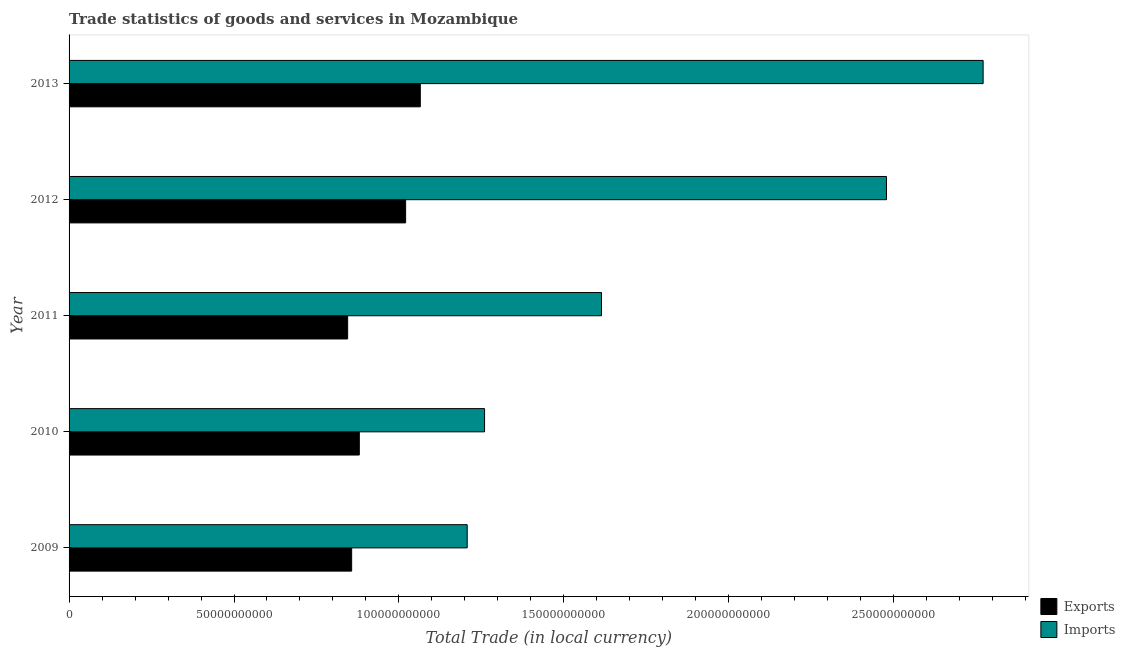How many different coloured bars are there?
Your answer should be compact. 2. How many bars are there on the 4th tick from the top?
Offer a terse response. 2. How many bars are there on the 5th tick from the bottom?
Give a very brief answer. 2. In how many cases, is the number of bars for a given year not equal to the number of legend labels?
Ensure brevity in your answer.  0. What is the export of goods and services in 2011?
Your answer should be very brief. 8.45e+1. Across all years, what is the maximum export of goods and services?
Give a very brief answer. 1.06e+11. Across all years, what is the minimum imports of goods and services?
Your answer should be compact. 1.21e+11. What is the total imports of goods and services in the graph?
Offer a terse response. 9.33e+11. What is the difference between the imports of goods and services in 2009 and that in 2011?
Give a very brief answer. -4.07e+1. What is the difference between the imports of goods and services in 2013 and the export of goods and services in 2012?
Provide a succinct answer. 1.75e+11. What is the average imports of goods and services per year?
Provide a succinct answer. 1.87e+11. In the year 2011, what is the difference between the export of goods and services and imports of goods and services?
Your answer should be compact. -7.70e+1. In how many years, is the imports of goods and services greater than 190000000000 LCU?
Your response must be concise. 2. What is the ratio of the export of goods and services in 2010 to that in 2012?
Your response must be concise. 0.86. Is the export of goods and services in 2009 less than that in 2013?
Offer a terse response. Yes. What is the difference between the highest and the second highest imports of goods and services?
Give a very brief answer. 2.93e+1. What is the difference between the highest and the lowest imports of goods and services?
Your answer should be compact. 1.56e+11. What does the 1st bar from the top in 2010 represents?
Provide a succinct answer. Imports. What does the 1st bar from the bottom in 2009 represents?
Provide a succinct answer. Exports. How many bars are there?
Your response must be concise. 10. Are all the bars in the graph horizontal?
Ensure brevity in your answer.  Yes. How many years are there in the graph?
Ensure brevity in your answer.  5. Are the values on the major ticks of X-axis written in scientific E-notation?
Your answer should be very brief. No. Does the graph contain any zero values?
Provide a succinct answer. No. Does the graph contain grids?
Ensure brevity in your answer.  No. Where does the legend appear in the graph?
Your response must be concise. Bottom right. What is the title of the graph?
Offer a very short reply. Trade statistics of goods and services in Mozambique. What is the label or title of the X-axis?
Your answer should be compact. Total Trade (in local currency). What is the Total Trade (in local currency) of Exports in 2009?
Your answer should be very brief. 8.57e+1. What is the Total Trade (in local currency) in Imports in 2009?
Offer a terse response. 1.21e+11. What is the Total Trade (in local currency) in Exports in 2010?
Your answer should be very brief. 8.80e+1. What is the Total Trade (in local currency) in Imports in 2010?
Your answer should be compact. 1.26e+11. What is the Total Trade (in local currency) in Exports in 2011?
Offer a terse response. 8.45e+1. What is the Total Trade (in local currency) in Imports in 2011?
Offer a terse response. 1.61e+11. What is the Total Trade (in local currency) of Exports in 2012?
Give a very brief answer. 1.02e+11. What is the Total Trade (in local currency) of Imports in 2012?
Your answer should be very brief. 2.48e+11. What is the Total Trade (in local currency) in Exports in 2013?
Offer a very short reply. 1.06e+11. What is the Total Trade (in local currency) of Imports in 2013?
Your answer should be compact. 2.77e+11. Across all years, what is the maximum Total Trade (in local currency) in Exports?
Your answer should be very brief. 1.06e+11. Across all years, what is the maximum Total Trade (in local currency) in Imports?
Your response must be concise. 2.77e+11. Across all years, what is the minimum Total Trade (in local currency) in Exports?
Your answer should be very brief. 8.45e+1. Across all years, what is the minimum Total Trade (in local currency) of Imports?
Your response must be concise. 1.21e+11. What is the total Total Trade (in local currency) in Exports in the graph?
Your answer should be very brief. 4.67e+11. What is the total Total Trade (in local currency) of Imports in the graph?
Give a very brief answer. 9.33e+11. What is the difference between the Total Trade (in local currency) in Exports in 2009 and that in 2010?
Keep it short and to the point. -2.32e+09. What is the difference between the Total Trade (in local currency) of Imports in 2009 and that in 2010?
Your response must be concise. -5.26e+09. What is the difference between the Total Trade (in local currency) in Exports in 2009 and that in 2011?
Provide a short and direct response. 1.22e+09. What is the difference between the Total Trade (in local currency) of Imports in 2009 and that in 2011?
Your answer should be compact. -4.07e+1. What is the difference between the Total Trade (in local currency) in Exports in 2009 and that in 2012?
Offer a very short reply. -1.64e+1. What is the difference between the Total Trade (in local currency) of Imports in 2009 and that in 2012?
Provide a succinct answer. -1.27e+11. What is the difference between the Total Trade (in local currency) of Exports in 2009 and that in 2013?
Provide a short and direct response. -2.08e+1. What is the difference between the Total Trade (in local currency) of Imports in 2009 and that in 2013?
Your answer should be compact. -1.56e+11. What is the difference between the Total Trade (in local currency) of Exports in 2010 and that in 2011?
Keep it short and to the point. 3.54e+09. What is the difference between the Total Trade (in local currency) in Imports in 2010 and that in 2011?
Your response must be concise. -3.55e+1. What is the difference between the Total Trade (in local currency) of Exports in 2010 and that in 2012?
Your answer should be compact. -1.40e+1. What is the difference between the Total Trade (in local currency) of Imports in 2010 and that in 2012?
Offer a terse response. -1.22e+11. What is the difference between the Total Trade (in local currency) in Exports in 2010 and that in 2013?
Offer a very short reply. -1.85e+1. What is the difference between the Total Trade (in local currency) in Imports in 2010 and that in 2013?
Offer a very short reply. -1.51e+11. What is the difference between the Total Trade (in local currency) of Exports in 2011 and that in 2012?
Offer a terse response. -1.76e+1. What is the difference between the Total Trade (in local currency) of Imports in 2011 and that in 2012?
Make the answer very short. -8.64e+1. What is the difference between the Total Trade (in local currency) in Exports in 2011 and that in 2013?
Provide a short and direct response. -2.20e+1. What is the difference between the Total Trade (in local currency) in Imports in 2011 and that in 2013?
Your answer should be compact. -1.16e+11. What is the difference between the Total Trade (in local currency) in Exports in 2012 and that in 2013?
Keep it short and to the point. -4.45e+09. What is the difference between the Total Trade (in local currency) in Imports in 2012 and that in 2013?
Your answer should be very brief. -2.93e+1. What is the difference between the Total Trade (in local currency) in Exports in 2009 and the Total Trade (in local currency) in Imports in 2010?
Your answer should be compact. -4.03e+1. What is the difference between the Total Trade (in local currency) in Exports in 2009 and the Total Trade (in local currency) in Imports in 2011?
Your response must be concise. -7.57e+1. What is the difference between the Total Trade (in local currency) of Exports in 2009 and the Total Trade (in local currency) of Imports in 2012?
Provide a short and direct response. -1.62e+11. What is the difference between the Total Trade (in local currency) of Exports in 2009 and the Total Trade (in local currency) of Imports in 2013?
Offer a very short reply. -1.91e+11. What is the difference between the Total Trade (in local currency) of Exports in 2010 and the Total Trade (in local currency) of Imports in 2011?
Your answer should be very brief. -7.34e+1. What is the difference between the Total Trade (in local currency) of Exports in 2010 and the Total Trade (in local currency) of Imports in 2012?
Your answer should be compact. -1.60e+11. What is the difference between the Total Trade (in local currency) of Exports in 2010 and the Total Trade (in local currency) of Imports in 2013?
Provide a succinct answer. -1.89e+11. What is the difference between the Total Trade (in local currency) in Exports in 2011 and the Total Trade (in local currency) in Imports in 2012?
Your response must be concise. -1.63e+11. What is the difference between the Total Trade (in local currency) of Exports in 2011 and the Total Trade (in local currency) of Imports in 2013?
Your answer should be compact. -1.93e+11. What is the difference between the Total Trade (in local currency) in Exports in 2012 and the Total Trade (in local currency) in Imports in 2013?
Your answer should be very brief. -1.75e+11. What is the average Total Trade (in local currency) in Exports per year?
Your response must be concise. 9.33e+1. What is the average Total Trade (in local currency) of Imports per year?
Offer a terse response. 1.87e+11. In the year 2009, what is the difference between the Total Trade (in local currency) in Exports and Total Trade (in local currency) in Imports?
Make the answer very short. -3.50e+1. In the year 2010, what is the difference between the Total Trade (in local currency) in Exports and Total Trade (in local currency) in Imports?
Your answer should be very brief. -3.80e+1. In the year 2011, what is the difference between the Total Trade (in local currency) in Exports and Total Trade (in local currency) in Imports?
Offer a very short reply. -7.70e+1. In the year 2012, what is the difference between the Total Trade (in local currency) in Exports and Total Trade (in local currency) in Imports?
Provide a short and direct response. -1.46e+11. In the year 2013, what is the difference between the Total Trade (in local currency) in Exports and Total Trade (in local currency) in Imports?
Give a very brief answer. -1.71e+11. What is the ratio of the Total Trade (in local currency) in Exports in 2009 to that in 2010?
Make the answer very short. 0.97. What is the ratio of the Total Trade (in local currency) of Imports in 2009 to that in 2010?
Ensure brevity in your answer.  0.96. What is the ratio of the Total Trade (in local currency) in Exports in 2009 to that in 2011?
Keep it short and to the point. 1.01. What is the ratio of the Total Trade (in local currency) in Imports in 2009 to that in 2011?
Give a very brief answer. 0.75. What is the ratio of the Total Trade (in local currency) of Exports in 2009 to that in 2012?
Your answer should be very brief. 0.84. What is the ratio of the Total Trade (in local currency) of Imports in 2009 to that in 2012?
Your answer should be very brief. 0.49. What is the ratio of the Total Trade (in local currency) of Exports in 2009 to that in 2013?
Provide a succinct answer. 0.8. What is the ratio of the Total Trade (in local currency) of Imports in 2009 to that in 2013?
Make the answer very short. 0.44. What is the ratio of the Total Trade (in local currency) in Exports in 2010 to that in 2011?
Offer a terse response. 1.04. What is the ratio of the Total Trade (in local currency) of Imports in 2010 to that in 2011?
Your response must be concise. 0.78. What is the ratio of the Total Trade (in local currency) in Exports in 2010 to that in 2012?
Offer a terse response. 0.86. What is the ratio of the Total Trade (in local currency) in Imports in 2010 to that in 2012?
Your response must be concise. 0.51. What is the ratio of the Total Trade (in local currency) in Exports in 2010 to that in 2013?
Your answer should be very brief. 0.83. What is the ratio of the Total Trade (in local currency) in Imports in 2010 to that in 2013?
Provide a short and direct response. 0.45. What is the ratio of the Total Trade (in local currency) of Exports in 2011 to that in 2012?
Offer a terse response. 0.83. What is the ratio of the Total Trade (in local currency) in Imports in 2011 to that in 2012?
Your response must be concise. 0.65. What is the ratio of the Total Trade (in local currency) of Exports in 2011 to that in 2013?
Offer a terse response. 0.79. What is the ratio of the Total Trade (in local currency) in Imports in 2011 to that in 2013?
Keep it short and to the point. 0.58. What is the ratio of the Total Trade (in local currency) in Exports in 2012 to that in 2013?
Your answer should be compact. 0.96. What is the ratio of the Total Trade (in local currency) of Imports in 2012 to that in 2013?
Offer a terse response. 0.89. What is the difference between the highest and the second highest Total Trade (in local currency) in Exports?
Your response must be concise. 4.45e+09. What is the difference between the highest and the second highest Total Trade (in local currency) in Imports?
Provide a succinct answer. 2.93e+1. What is the difference between the highest and the lowest Total Trade (in local currency) in Exports?
Provide a succinct answer. 2.20e+1. What is the difference between the highest and the lowest Total Trade (in local currency) in Imports?
Your response must be concise. 1.56e+11. 